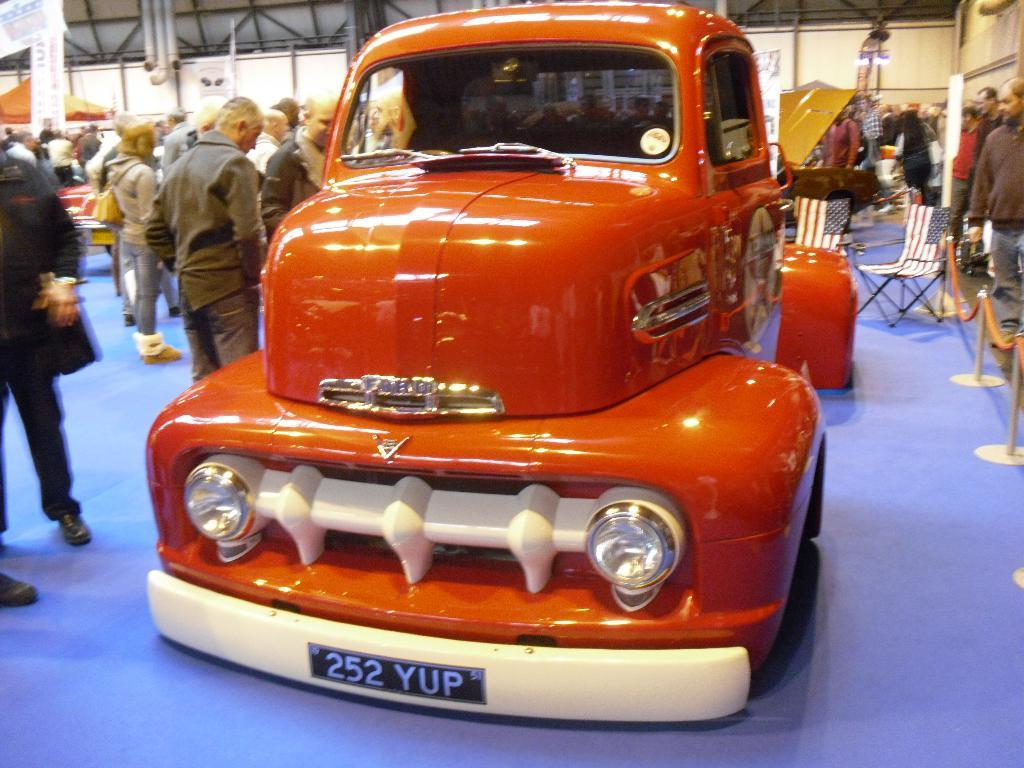What is on the floor in the image? There is a vehicle on the floor in the image. Who or what can be seen standing in the image? There are people standing in the image. What type of furniture is on the right side of the image? There is a sitting chair on the right side of the image. What type of fiction is being read by the people in the image? There is no indication of any fiction being read in the image. Can you touch the vehicle in the image? The image is a visual representation, so you cannot physically touch the vehicle in the image. 